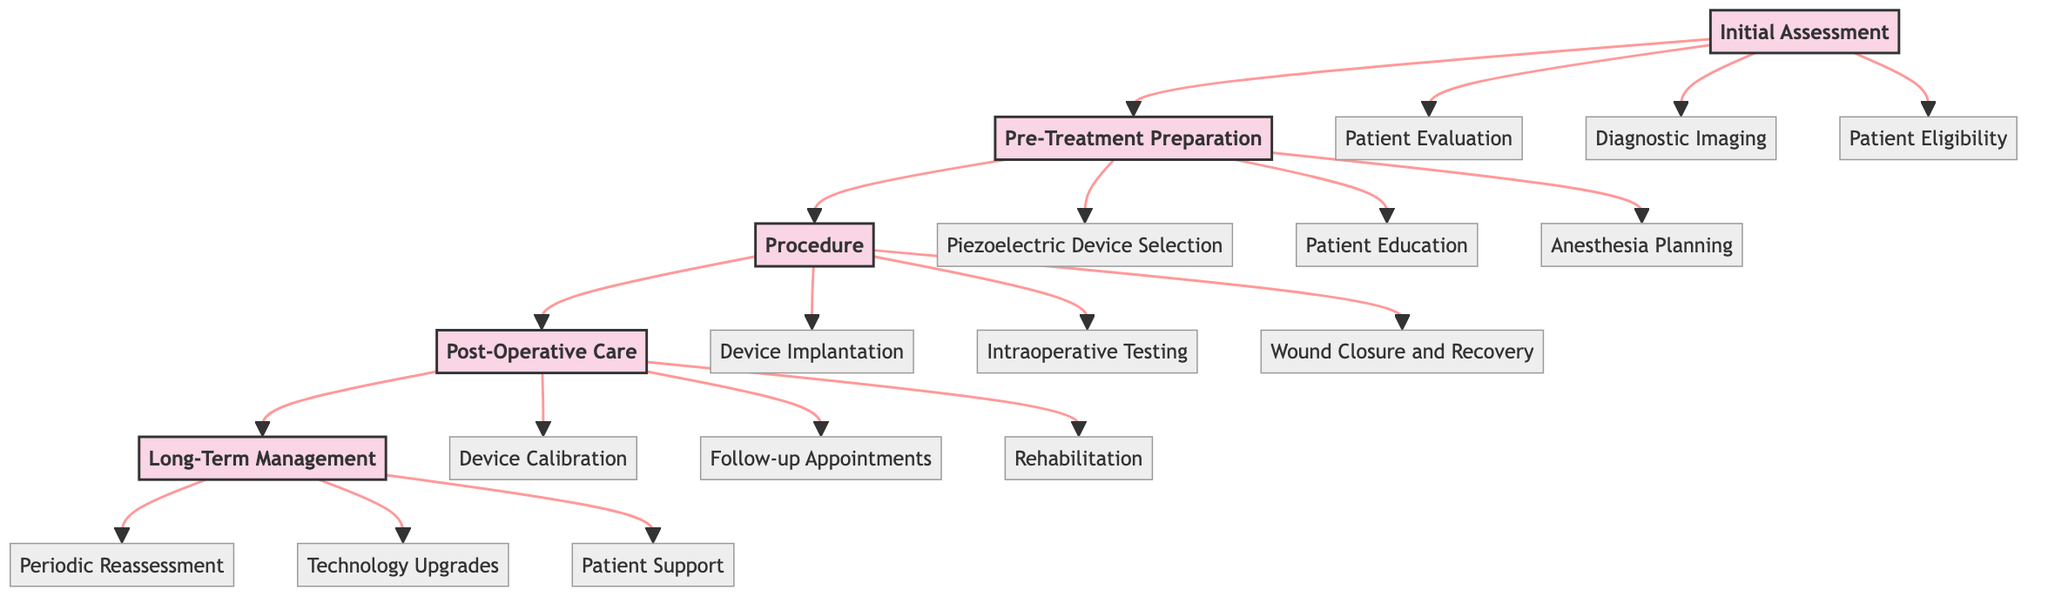What is the first step in the Clinical Pathway? The first stage is "Initial Assessment", which contains three steps: Patient Evaluation, Diagnostic Imaging, and Patient Eligibility.
Answer: Initial Assessment How many stages are there in the Clinical Pathway? The diagram contains five stages: Initial Assessment, Pre-Treatment Preparation, Procedure, Post-Operative Care, and Long-Term Management.
Answer: Five What step follows "Intraoperative Testing"? The sequence shows that "Wound Closure and Recovery" comes after "Intraoperative Testing" in the Procedure stage.
Answer: Wound Closure and Recovery What is the final stage of the Clinical Pathway? The last stage in the pathway is "Long-Term Management", which focuses on ongoing evaluation and patient support post-treatment.
Answer: Long-Term Management Which step includes patient education? "Patient Education" is part of the "Pre-Treatment Preparation" stage and aims to inform the patient about the procedure and its implications.
Answer: Patient Education What are the three steps under "Post-Operative Care"? The three steps are "Device Calibration", "Follow-up Appointments", and "Rehabilitation", which provide critical support after surgery.
Answer: Device Calibration, Follow-up Appointments, Rehabilitation What is the role of "Periodic Reassessment" in the pathway? "Periodic Reassessment" takes place in the Long-Term Management stage, focusing on the ongoing evaluation of pain management and device performance.
Answer: Ongoing evaluation How many steps are in the "Procedure" stage? In the Procedure stage, there are three steps: "Device Implantation," "Intraoperative Testing," and "Wound Closure and Recovery."
Answer: Three What type of materials are selected in the "Pre-Treatment Preparation"? During the "Piezoelectric Device Selection" step, appropriate piezoelectric materials are chosen, such as lead zirconate titanate or barium titanate.
Answer: Piezoelectric materials 